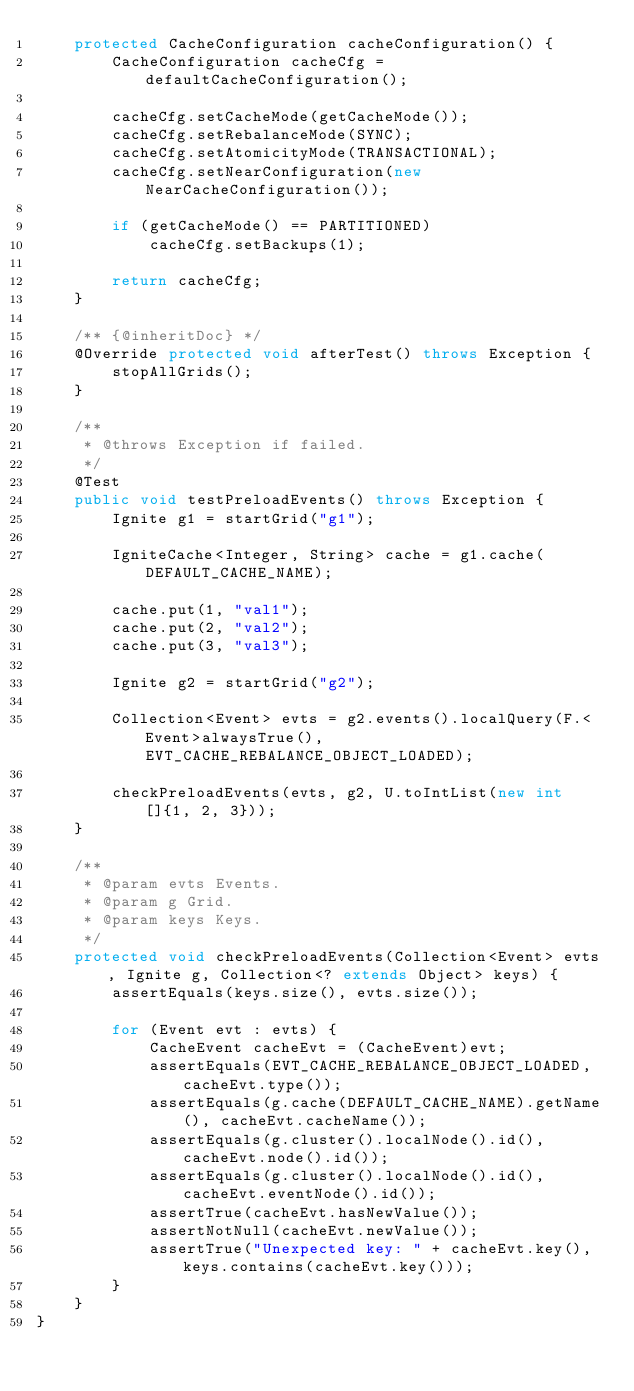<code> <loc_0><loc_0><loc_500><loc_500><_Java_>    protected CacheConfiguration cacheConfiguration() {
        CacheConfiguration cacheCfg = defaultCacheConfiguration();

        cacheCfg.setCacheMode(getCacheMode());
        cacheCfg.setRebalanceMode(SYNC);
        cacheCfg.setAtomicityMode(TRANSACTIONAL);
        cacheCfg.setNearConfiguration(new NearCacheConfiguration());

        if (getCacheMode() == PARTITIONED)
            cacheCfg.setBackups(1);

        return cacheCfg;
    }

    /** {@inheritDoc} */
    @Override protected void afterTest() throws Exception {
        stopAllGrids();
    }

    /**
     * @throws Exception if failed.
     */
    @Test
    public void testPreloadEvents() throws Exception {
        Ignite g1 = startGrid("g1");

        IgniteCache<Integer, String> cache = g1.cache(DEFAULT_CACHE_NAME);

        cache.put(1, "val1");
        cache.put(2, "val2");
        cache.put(3, "val3");

        Ignite g2 = startGrid("g2");

        Collection<Event> evts = g2.events().localQuery(F.<Event>alwaysTrue(), EVT_CACHE_REBALANCE_OBJECT_LOADED);

        checkPreloadEvents(evts, g2, U.toIntList(new int[]{1, 2, 3}));
    }

    /**
     * @param evts Events.
     * @param g Grid.
     * @param keys Keys.
     */
    protected void checkPreloadEvents(Collection<Event> evts, Ignite g, Collection<? extends Object> keys) {
        assertEquals(keys.size(), evts.size());

        for (Event evt : evts) {
            CacheEvent cacheEvt = (CacheEvent)evt;
            assertEquals(EVT_CACHE_REBALANCE_OBJECT_LOADED, cacheEvt.type());
            assertEquals(g.cache(DEFAULT_CACHE_NAME).getName(), cacheEvt.cacheName());
            assertEquals(g.cluster().localNode().id(), cacheEvt.node().id());
            assertEquals(g.cluster().localNode().id(), cacheEvt.eventNode().id());
            assertTrue(cacheEvt.hasNewValue());
            assertNotNull(cacheEvt.newValue());
            assertTrue("Unexpected key: " + cacheEvt.key(), keys.contains(cacheEvt.key()));
        }
    }
}
</code> 